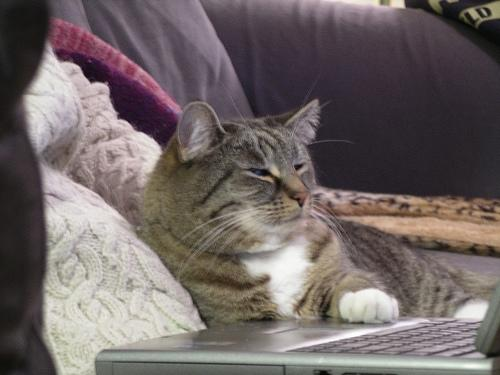What is similar to the long things on the animal's face? Please explain your reasoning. antenna. The antenna is similar. 